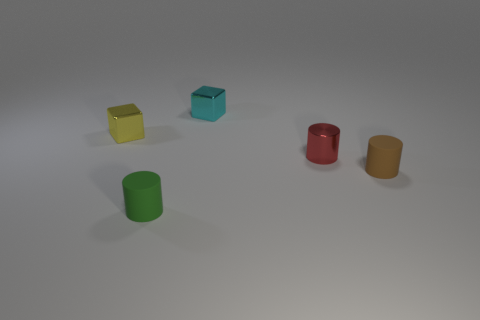Subtract all cylinders. How many objects are left? 2 Add 5 tiny green rubber objects. How many objects exist? 10 Add 5 large red rubber objects. How many large red rubber objects exist? 5 Subtract 1 green cylinders. How many objects are left? 4 Subtract all small cylinders. Subtract all green things. How many objects are left? 1 Add 3 tiny brown objects. How many tiny brown objects are left? 4 